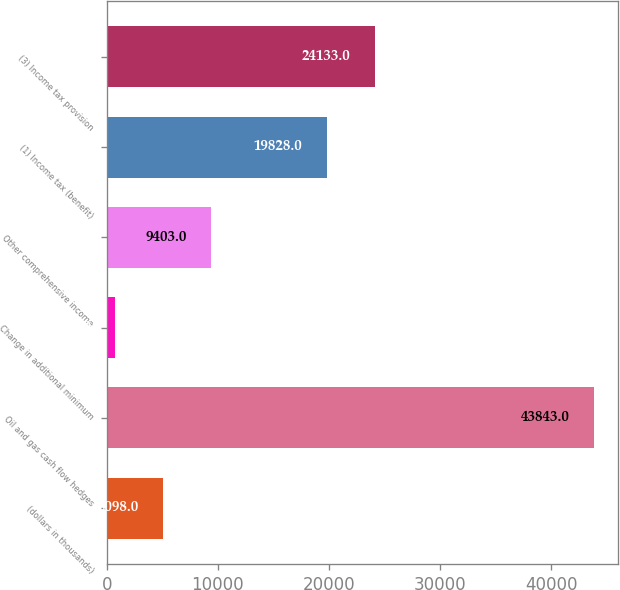Convert chart. <chart><loc_0><loc_0><loc_500><loc_500><bar_chart><fcel>(dollars in thousands)<fcel>Oil and gas cash flow hedges<fcel>Change in additional minimum<fcel>Other comprehensive income<fcel>(1) Income tax (benefit)<fcel>(3) Income tax provision<nl><fcel>5098<fcel>43843<fcel>793<fcel>9403<fcel>19828<fcel>24133<nl></chart> 